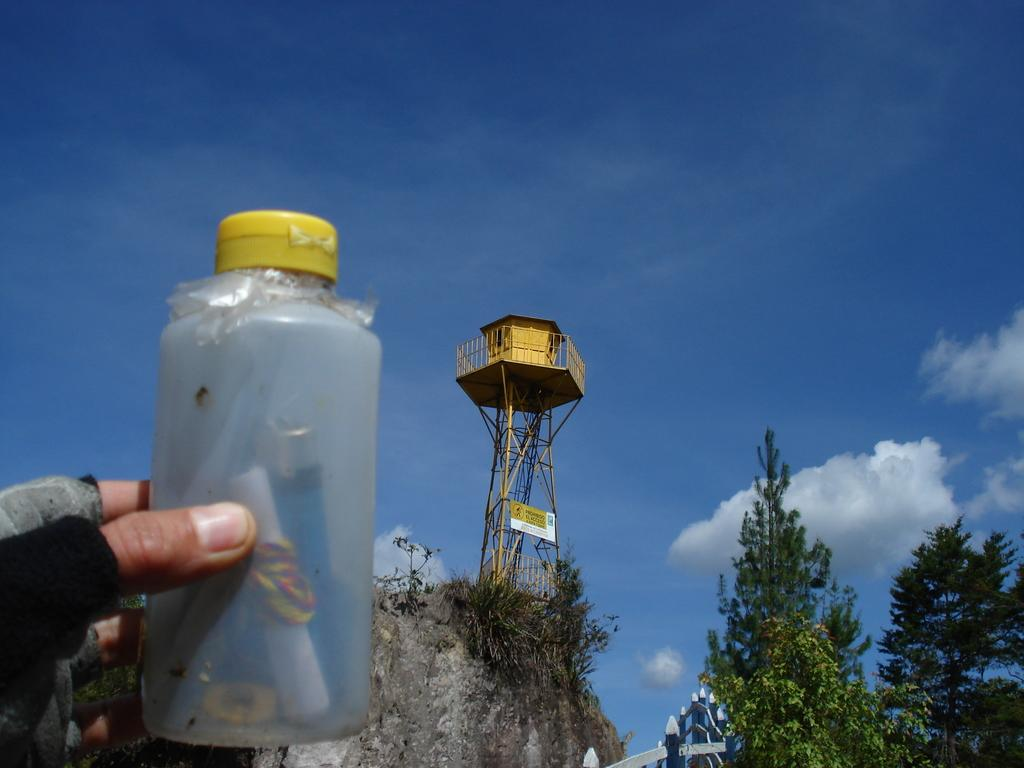What is the main structure in the image? There is a tower in the image. Is there any additional space above the tower? Yes, there is a room above the tower. What type of natural elements can be seen in the image? There are trees in the image. How would you describe the sky in the image? The sky appears drowsy or hazy in the image. What is the man in the image holding? The man is holding a bottle. What is inside the bottle? The bottle contains a paper. What type of disease can be seen spreading through the trees in the image? There is no disease visible in the image; it only shows trees and a tower. Is there a lake present in the image? No, there is no lake visible in the image. 